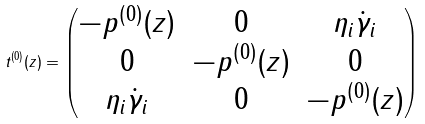Convert formula to latex. <formula><loc_0><loc_0><loc_500><loc_500>t ^ { ( 0 ) } ( z ) = \begin{pmatrix} - p ^ { ( 0 ) } ( z ) & 0 & \eta _ { i } \dot { \gamma } _ { i } \\ 0 & - p ^ { ( 0 ) } ( z ) & 0 \\ \eta _ { i } \dot { \gamma } _ { i } & 0 & - p ^ { ( 0 ) } ( z ) \end{pmatrix}</formula> 